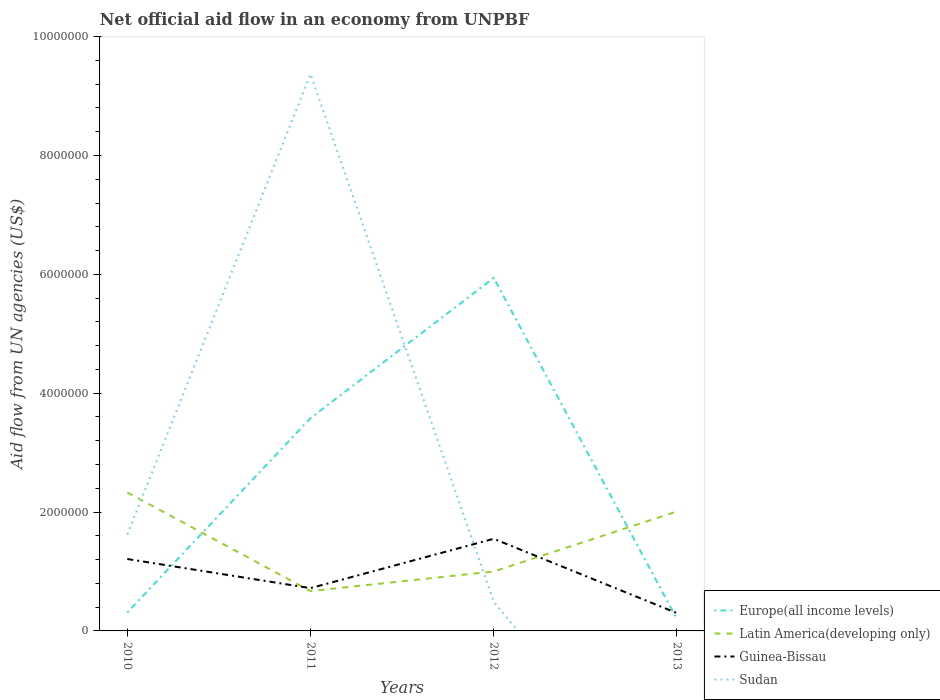How many different coloured lines are there?
Offer a terse response. 4. Does the line corresponding to Guinea-Bissau intersect with the line corresponding to Sudan?
Provide a short and direct response. Yes. Is the number of lines equal to the number of legend labels?
Your answer should be compact. No. What is the total net official aid flow in Europe(all income levels) in the graph?
Ensure brevity in your answer.  1.10e+05. What is the difference between the highest and the second highest net official aid flow in Europe(all income levels)?
Provide a short and direct response. 5.74e+06. What is the difference between the highest and the lowest net official aid flow in Guinea-Bissau?
Ensure brevity in your answer.  2. How many lines are there?
Make the answer very short. 4. How are the legend labels stacked?
Offer a terse response. Vertical. What is the title of the graph?
Provide a short and direct response. Net official aid flow in an economy from UNPBF. What is the label or title of the X-axis?
Your answer should be compact. Years. What is the label or title of the Y-axis?
Your answer should be very brief. Aid flow from UN agencies (US$). What is the Aid flow from UN agencies (US$) of Latin America(developing only) in 2010?
Give a very brief answer. 2.33e+06. What is the Aid flow from UN agencies (US$) of Guinea-Bissau in 2010?
Provide a succinct answer. 1.21e+06. What is the Aid flow from UN agencies (US$) in Sudan in 2010?
Give a very brief answer. 1.62e+06. What is the Aid flow from UN agencies (US$) of Europe(all income levels) in 2011?
Give a very brief answer. 3.58e+06. What is the Aid flow from UN agencies (US$) of Latin America(developing only) in 2011?
Your response must be concise. 6.70e+05. What is the Aid flow from UN agencies (US$) of Guinea-Bissau in 2011?
Your answer should be very brief. 7.20e+05. What is the Aid flow from UN agencies (US$) of Sudan in 2011?
Ensure brevity in your answer.  9.37e+06. What is the Aid flow from UN agencies (US$) in Europe(all income levels) in 2012?
Ensure brevity in your answer.  5.94e+06. What is the Aid flow from UN agencies (US$) of Guinea-Bissau in 2012?
Make the answer very short. 1.55e+06. What is the Aid flow from UN agencies (US$) in Latin America(developing only) in 2013?
Give a very brief answer. 2.01e+06. What is the Aid flow from UN agencies (US$) of Guinea-Bissau in 2013?
Provide a short and direct response. 3.00e+05. What is the Aid flow from UN agencies (US$) in Sudan in 2013?
Your response must be concise. 0. Across all years, what is the maximum Aid flow from UN agencies (US$) in Europe(all income levels)?
Your answer should be compact. 5.94e+06. Across all years, what is the maximum Aid flow from UN agencies (US$) in Latin America(developing only)?
Keep it short and to the point. 2.33e+06. Across all years, what is the maximum Aid flow from UN agencies (US$) of Guinea-Bissau?
Give a very brief answer. 1.55e+06. Across all years, what is the maximum Aid flow from UN agencies (US$) of Sudan?
Your answer should be very brief. 9.37e+06. Across all years, what is the minimum Aid flow from UN agencies (US$) in Latin America(developing only)?
Give a very brief answer. 6.70e+05. Across all years, what is the minimum Aid flow from UN agencies (US$) of Guinea-Bissau?
Provide a short and direct response. 3.00e+05. What is the total Aid flow from UN agencies (US$) of Europe(all income levels) in the graph?
Offer a terse response. 1.00e+07. What is the total Aid flow from UN agencies (US$) of Latin America(developing only) in the graph?
Your response must be concise. 6.01e+06. What is the total Aid flow from UN agencies (US$) of Guinea-Bissau in the graph?
Your answer should be compact. 3.78e+06. What is the total Aid flow from UN agencies (US$) in Sudan in the graph?
Provide a short and direct response. 1.15e+07. What is the difference between the Aid flow from UN agencies (US$) of Europe(all income levels) in 2010 and that in 2011?
Your answer should be compact. -3.27e+06. What is the difference between the Aid flow from UN agencies (US$) in Latin America(developing only) in 2010 and that in 2011?
Offer a very short reply. 1.66e+06. What is the difference between the Aid flow from UN agencies (US$) in Guinea-Bissau in 2010 and that in 2011?
Keep it short and to the point. 4.90e+05. What is the difference between the Aid flow from UN agencies (US$) of Sudan in 2010 and that in 2011?
Provide a succinct answer. -7.75e+06. What is the difference between the Aid flow from UN agencies (US$) in Europe(all income levels) in 2010 and that in 2012?
Provide a succinct answer. -5.63e+06. What is the difference between the Aid flow from UN agencies (US$) in Latin America(developing only) in 2010 and that in 2012?
Ensure brevity in your answer.  1.33e+06. What is the difference between the Aid flow from UN agencies (US$) in Sudan in 2010 and that in 2012?
Provide a short and direct response. 1.13e+06. What is the difference between the Aid flow from UN agencies (US$) of Europe(all income levels) in 2010 and that in 2013?
Provide a succinct answer. 1.10e+05. What is the difference between the Aid flow from UN agencies (US$) of Latin America(developing only) in 2010 and that in 2013?
Give a very brief answer. 3.20e+05. What is the difference between the Aid flow from UN agencies (US$) in Guinea-Bissau in 2010 and that in 2013?
Keep it short and to the point. 9.10e+05. What is the difference between the Aid flow from UN agencies (US$) of Europe(all income levels) in 2011 and that in 2012?
Provide a succinct answer. -2.36e+06. What is the difference between the Aid flow from UN agencies (US$) of Latin America(developing only) in 2011 and that in 2012?
Your answer should be very brief. -3.30e+05. What is the difference between the Aid flow from UN agencies (US$) of Guinea-Bissau in 2011 and that in 2012?
Keep it short and to the point. -8.30e+05. What is the difference between the Aid flow from UN agencies (US$) of Sudan in 2011 and that in 2012?
Your response must be concise. 8.88e+06. What is the difference between the Aid flow from UN agencies (US$) in Europe(all income levels) in 2011 and that in 2013?
Your answer should be compact. 3.38e+06. What is the difference between the Aid flow from UN agencies (US$) in Latin America(developing only) in 2011 and that in 2013?
Offer a terse response. -1.34e+06. What is the difference between the Aid flow from UN agencies (US$) in Guinea-Bissau in 2011 and that in 2013?
Offer a terse response. 4.20e+05. What is the difference between the Aid flow from UN agencies (US$) of Europe(all income levels) in 2012 and that in 2013?
Keep it short and to the point. 5.74e+06. What is the difference between the Aid flow from UN agencies (US$) of Latin America(developing only) in 2012 and that in 2013?
Your response must be concise. -1.01e+06. What is the difference between the Aid flow from UN agencies (US$) of Guinea-Bissau in 2012 and that in 2013?
Your answer should be very brief. 1.25e+06. What is the difference between the Aid flow from UN agencies (US$) of Europe(all income levels) in 2010 and the Aid flow from UN agencies (US$) of Latin America(developing only) in 2011?
Your answer should be compact. -3.60e+05. What is the difference between the Aid flow from UN agencies (US$) in Europe(all income levels) in 2010 and the Aid flow from UN agencies (US$) in Guinea-Bissau in 2011?
Offer a very short reply. -4.10e+05. What is the difference between the Aid flow from UN agencies (US$) in Europe(all income levels) in 2010 and the Aid flow from UN agencies (US$) in Sudan in 2011?
Your answer should be compact. -9.06e+06. What is the difference between the Aid flow from UN agencies (US$) in Latin America(developing only) in 2010 and the Aid flow from UN agencies (US$) in Guinea-Bissau in 2011?
Your answer should be compact. 1.61e+06. What is the difference between the Aid flow from UN agencies (US$) of Latin America(developing only) in 2010 and the Aid flow from UN agencies (US$) of Sudan in 2011?
Offer a very short reply. -7.04e+06. What is the difference between the Aid flow from UN agencies (US$) of Guinea-Bissau in 2010 and the Aid flow from UN agencies (US$) of Sudan in 2011?
Ensure brevity in your answer.  -8.16e+06. What is the difference between the Aid flow from UN agencies (US$) of Europe(all income levels) in 2010 and the Aid flow from UN agencies (US$) of Latin America(developing only) in 2012?
Your answer should be very brief. -6.90e+05. What is the difference between the Aid flow from UN agencies (US$) in Europe(all income levels) in 2010 and the Aid flow from UN agencies (US$) in Guinea-Bissau in 2012?
Your response must be concise. -1.24e+06. What is the difference between the Aid flow from UN agencies (US$) in Latin America(developing only) in 2010 and the Aid flow from UN agencies (US$) in Guinea-Bissau in 2012?
Your answer should be compact. 7.80e+05. What is the difference between the Aid flow from UN agencies (US$) in Latin America(developing only) in 2010 and the Aid flow from UN agencies (US$) in Sudan in 2012?
Make the answer very short. 1.84e+06. What is the difference between the Aid flow from UN agencies (US$) of Guinea-Bissau in 2010 and the Aid flow from UN agencies (US$) of Sudan in 2012?
Keep it short and to the point. 7.20e+05. What is the difference between the Aid flow from UN agencies (US$) of Europe(all income levels) in 2010 and the Aid flow from UN agencies (US$) of Latin America(developing only) in 2013?
Make the answer very short. -1.70e+06. What is the difference between the Aid flow from UN agencies (US$) of Latin America(developing only) in 2010 and the Aid flow from UN agencies (US$) of Guinea-Bissau in 2013?
Your answer should be compact. 2.03e+06. What is the difference between the Aid flow from UN agencies (US$) of Europe(all income levels) in 2011 and the Aid flow from UN agencies (US$) of Latin America(developing only) in 2012?
Offer a terse response. 2.58e+06. What is the difference between the Aid flow from UN agencies (US$) in Europe(all income levels) in 2011 and the Aid flow from UN agencies (US$) in Guinea-Bissau in 2012?
Offer a very short reply. 2.03e+06. What is the difference between the Aid flow from UN agencies (US$) of Europe(all income levels) in 2011 and the Aid flow from UN agencies (US$) of Sudan in 2012?
Your response must be concise. 3.09e+06. What is the difference between the Aid flow from UN agencies (US$) in Latin America(developing only) in 2011 and the Aid flow from UN agencies (US$) in Guinea-Bissau in 2012?
Make the answer very short. -8.80e+05. What is the difference between the Aid flow from UN agencies (US$) in Europe(all income levels) in 2011 and the Aid flow from UN agencies (US$) in Latin America(developing only) in 2013?
Offer a terse response. 1.57e+06. What is the difference between the Aid flow from UN agencies (US$) of Europe(all income levels) in 2011 and the Aid flow from UN agencies (US$) of Guinea-Bissau in 2013?
Make the answer very short. 3.28e+06. What is the difference between the Aid flow from UN agencies (US$) in Europe(all income levels) in 2012 and the Aid flow from UN agencies (US$) in Latin America(developing only) in 2013?
Ensure brevity in your answer.  3.93e+06. What is the difference between the Aid flow from UN agencies (US$) of Europe(all income levels) in 2012 and the Aid flow from UN agencies (US$) of Guinea-Bissau in 2013?
Keep it short and to the point. 5.64e+06. What is the average Aid flow from UN agencies (US$) in Europe(all income levels) per year?
Provide a succinct answer. 2.51e+06. What is the average Aid flow from UN agencies (US$) in Latin America(developing only) per year?
Offer a terse response. 1.50e+06. What is the average Aid flow from UN agencies (US$) in Guinea-Bissau per year?
Offer a terse response. 9.45e+05. What is the average Aid flow from UN agencies (US$) of Sudan per year?
Offer a terse response. 2.87e+06. In the year 2010, what is the difference between the Aid flow from UN agencies (US$) in Europe(all income levels) and Aid flow from UN agencies (US$) in Latin America(developing only)?
Your answer should be compact. -2.02e+06. In the year 2010, what is the difference between the Aid flow from UN agencies (US$) in Europe(all income levels) and Aid flow from UN agencies (US$) in Guinea-Bissau?
Offer a terse response. -9.00e+05. In the year 2010, what is the difference between the Aid flow from UN agencies (US$) in Europe(all income levels) and Aid flow from UN agencies (US$) in Sudan?
Make the answer very short. -1.31e+06. In the year 2010, what is the difference between the Aid flow from UN agencies (US$) of Latin America(developing only) and Aid flow from UN agencies (US$) of Guinea-Bissau?
Provide a succinct answer. 1.12e+06. In the year 2010, what is the difference between the Aid flow from UN agencies (US$) of Latin America(developing only) and Aid flow from UN agencies (US$) of Sudan?
Provide a succinct answer. 7.10e+05. In the year 2010, what is the difference between the Aid flow from UN agencies (US$) of Guinea-Bissau and Aid flow from UN agencies (US$) of Sudan?
Your answer should be very brief. -4.10e+05. In the year 2011, what is the difference between the Aid flow from UN agencies (US$) in Europe(all income levels) and Aid flow from UN agencies (US$) in Latin America(developing only)?
Keep it short and to the point. 2.91e+06. In the year 2011, what is the difference between the Aid flow from UN agencies (US$) of Europe(all income levels) and Aid flow from UN agencies (US$) of Guinea-Bissau?
Offer a very short reply. 2.86e+06. In the year 2011, what is the difference between the Aid flow from UN agencies (US$) of Europe(all income levels) and Aid flow from UN agencies (US$) of Sudan?
Your answer should be compact. -5.79e+06. In the year 2011, what is the difference between the Aid flow from UN agencies (US$) in Latin America(developing only) and Aid flow from UN agencies (US$) in Guinea-Bissau?
Offer a terse response. -5.00e+04. In the year 2011, what is the difference between the Aid flow from UN agencies (US$) of Latin America(developing only) and Aid flow from UN agencies (US$) of Sudan?
Offer a terse response. -8.70e+06. In the year 2011, what is the difference between the Aid flow from UN agencies (US$) of Guinea-Bissau and Aid flow from UN agencies (US$) of Sudan?
Your response must be concise. -8.65e+06. In the year 2012, what is the difference between the Aid flow from UN agencies (US$) in Europe(all income levels) and Aid flow from UN agencies (US$) in Latin America(developing only)?
Make the answer very short. 4.94e+06. In the year 2012, what is the difference between the Aid flow from UN agencies (US$) in Europe(all income levels) and Aid flow from UN agencies (US$) in Guinea-Bissau?
Give a very brief answer. 4.39e+06. In the year 2012, what is the difference between the Aid flow from UN agencies (US$) of Europe(all income levels) and Aid flow from UN agencies (US$) of Sudan?
Provide a succinct answer. 5.45e+06. In the year 2012, what is the difference between the Aid flow from UN agencies (US$) in Latin America(developing only) and Aid flow from UN agencies (US$) in Guinea-Bissau?
Ensure brevity in your answer.  -5.50e+05. In the year 2012, what is the difference between the Aid flow from UN agencies (US$) in Latin America(developing only) and Aid flow from UN agencies (US$) in Sudan?
Provide a succinct answer. 5.10e+05. In the year 2012, what is the difference between the Aid flow from UN agencies (US$) of Guinea-Bissau and Aid flow from UN agencies (US$) of Sudan?
Provide a short and direct response. 1.06e+06. In the year 2013, what is the difference between the Aid flow from UN agencies (US$) of Europe(all income levels) and Aid flow from UN agencies (US$) of Latin America(developing only)?
Your answer should be compact. -1.81e+06. In the year 2013, what is the difference between the Aid flow from UN agencies (US$) in Europe(all income levels) and Aid flow from UN agencies (US$) in Guinea-Bissau?
Ensure brevity in your answer.  -1.00e+05. In the year 2013, what is the difference between the Aid flow from UN agencies (US$) of Latin America(developing only) and Aid flow from UN agencies (US$) of Guinea-Bissau?
Your response must be concise. 1.71e+06. What is the ratio of the Aid flow from UN agencies (US$) in Europe(all income levels) in 2010 to that in 2011?
Ensure brevity in your answer.  0.09. What is the ratio of the Aid flow from UN agencies (US$) in Latin America(developing only) in 2010 to that in 2011?
Make the answer very short. 3.48. What is the ratio of the Aid flow from UN agencies (US$) of Guinea-Bissau in 2010 to that in 2011?
Your response must be concise. 1.68. What is the ratio of the Aid flow from UN agencies (US$) in Sudan in 2010 to that in 2011?
Provide a short and direct response. 0.17. What is the ratio of the Aid flow from UN agencies (US$) in Europe(all income levels) in 2010 to that in 2012?
Give a very brief answer. 0.05. What is the ratio of the Aid flow from UN agencies (US$) of Latin America(developing only) in 2010 to that in 2012?
Keep it short and to the point. 2.33. What is the ratio of the Aid flow from UN agencies (US$) in Guinea-Bissau in 2010 to that in 2012?
Offer a very short reply. 0.78. What is the ratio of the Aid flow from UN agencies (US$) in Sudan in 2010 to that in 2012?
Offer a terse response. 3.31. What is the ratio of the Aid flow from UN agencies (US$) of Europe(all income levels) in 2010 to that in 2013?
Your response must be concise. 1.55. What is the ratio of the Aid flow from UN agencies (US$) in Latin America(developing only) in 2010 to that in 2013?
Keep it short and to the point. 1.16. What is the ratio of the Aid flow from UN agencies (US$) in Guinea-Bissau in 2010 to that in 2013?
Your answer should be compact. 4.03. What is the ratio of the Aid flow from UN agencies (US$) in Europe(all income levels) in 2011 to that in 2012?
Your response must be concise. 0.6. What is the ratio of the Aid flow from UN agencies (US$) of Latin America(developing only) in 2011 to that in 2012?
Your answer should be compact. 0.67. What is the ratio of the Aid flow from UN agencies (US$) in Guinea-Bissau in 2011 to that in 2012?
Offer a very short reply. 0.46. What is the ratio of the Aid flow from UN agencies (US$) of Sudan in 2011 to that in 2012?
Provide a short and direct response. 19.12. What is the ratio of the Aid flow from UN agencies (US$) in Europe(all income levels) in 2012 to that in 2013?
Ensure brevity in your answer.  29.7. What is the ratio of the Aid flow from UN agencies (US$) of Latin America(developing only) in 2012 to that in 2013?
Provide a short and direct response. 0.5. What is the ratio of the Aid flow from UN agencies (US$) in Guinea-Bissau in 2012 to that in 2013?
Your response must be concise. 5.17. What is the difference between the highest and the second highest Aid flow from UN agencies (US$) of Europe(all income levels)?
Ensure brevity in your answer.  2.36e+06. What is the difference between the highest and the second highest Aid flow from UN agencies (US$) of Latin America(developing only)?
Offer a terse response. 3.20e+05. What is the difference between the highest and the second highest Aid flow from UN agencies (US$) of Sudan?
Provide a succinct answer. 7.75e+06. What is the difference between the highest and the lowest Aid flow from UN agencies (US$) in Europe(all income levels)?
Provide a short and direct response. 5.74e+06. What is the difference between the highest and the lowest Aid flow from UN agencies (US$) of Latin America(developing only)?
Give a very brief answer. 1.66e+06. What is the difference between the highest and the lowest Aid flow from UN agencies (US$) in Guinea-Bissau?
Offer a very short reply. 1.25e+06. What is the difference between the highest and the lowest Aid flow from UN agencies (US$) in Sudan?
Your answer should be very brief. 9.37e+06. 